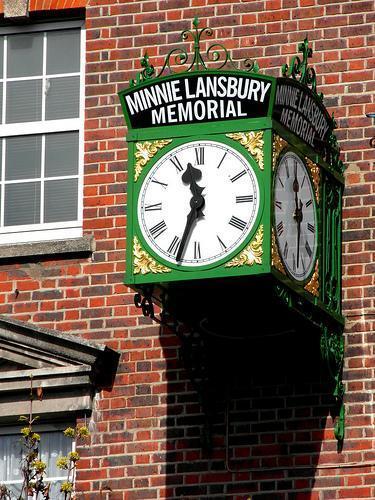How many clocks are visible?
Give a very brief answer. 2. How many elephants are pictured?
Give a very brief answer. 0. 